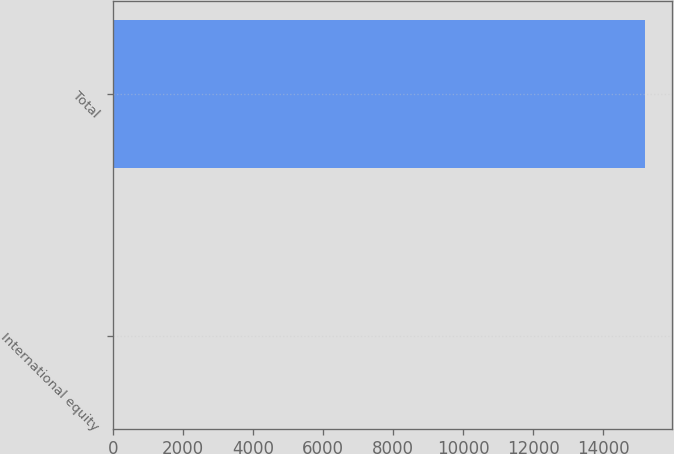<chart> <loc_0><loc_0><loc_500><loc_500><bar_chart><fcel>International equity<fcel>Total<nl><fcel>24<fcel>15202<nl></chart> 